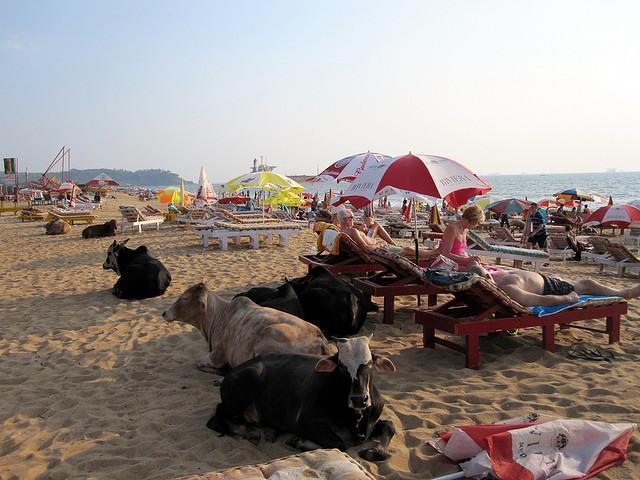How many cows are visible?
Give a very brief answer. 4. How many chairs can you see?
Give a very brief answer. 3. How many baby elephants are pictured?
Give a very brief answer. 0. 